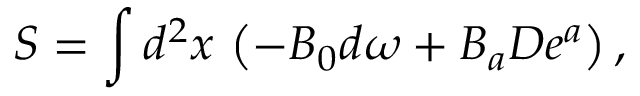Convert formula to latex. <formula><loc_0><loc_0><loc_500><loc_500>S = \int d ^ { 2 } x \, \left ( - B _ { 0 } d \omega + B _ { a } D e ^ { a } \right ) ,</formula> 